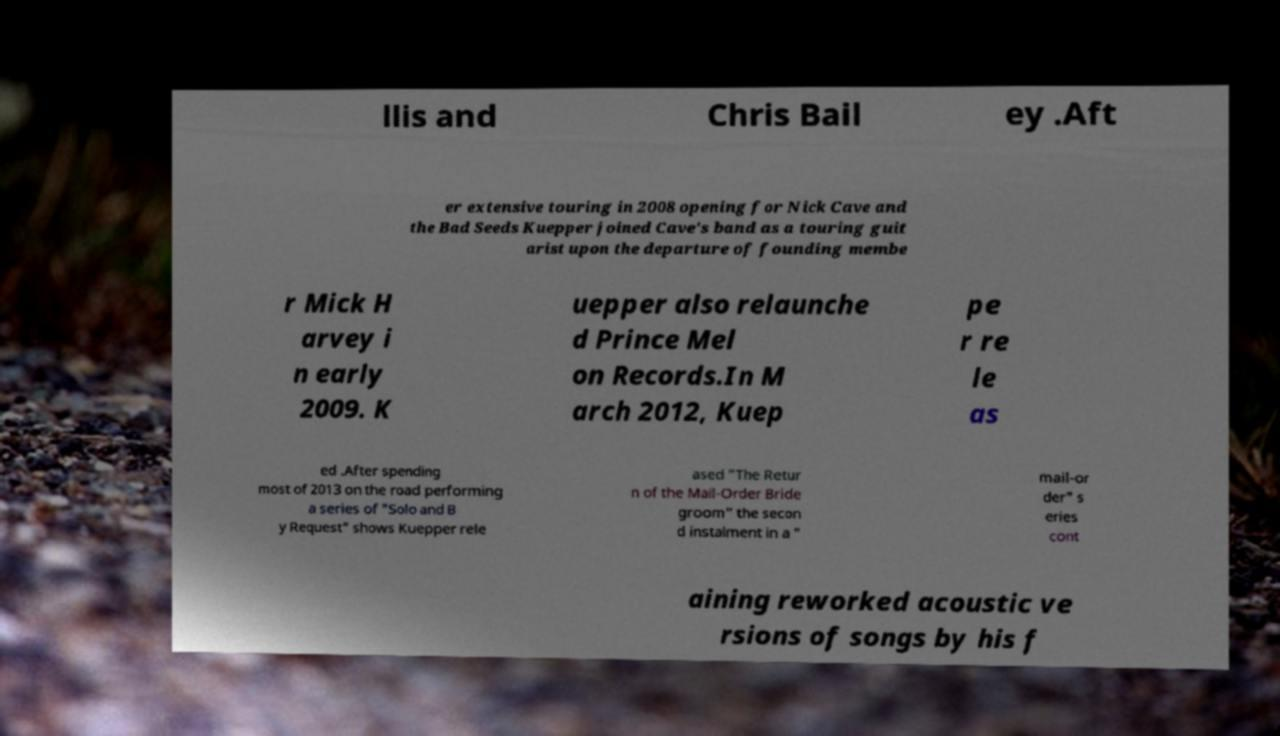Please read and relay the text visible in this image. What does it say? llis and Chris Bail ey .Aft er extensive touring in 2008 opening for Nick Cave and the Bad Seeds Kuepper joined Cave's band as a touring guit arist upon the departure of founding membe r Mick H arvey i n early 2009. K uepper also relaunche d Prince Mel on Records.In M arch 2012, Kuep pe r re le as ed .After spending most of 2013 on the road performing a series of "Solo and B y Request" shows Kuepper rele ased "The Retur n of the Mail-Order Bride groom" the secon d instalment in a " mail-or der" s eries cont aining reworked acoustic ve rsions of songs by his f 